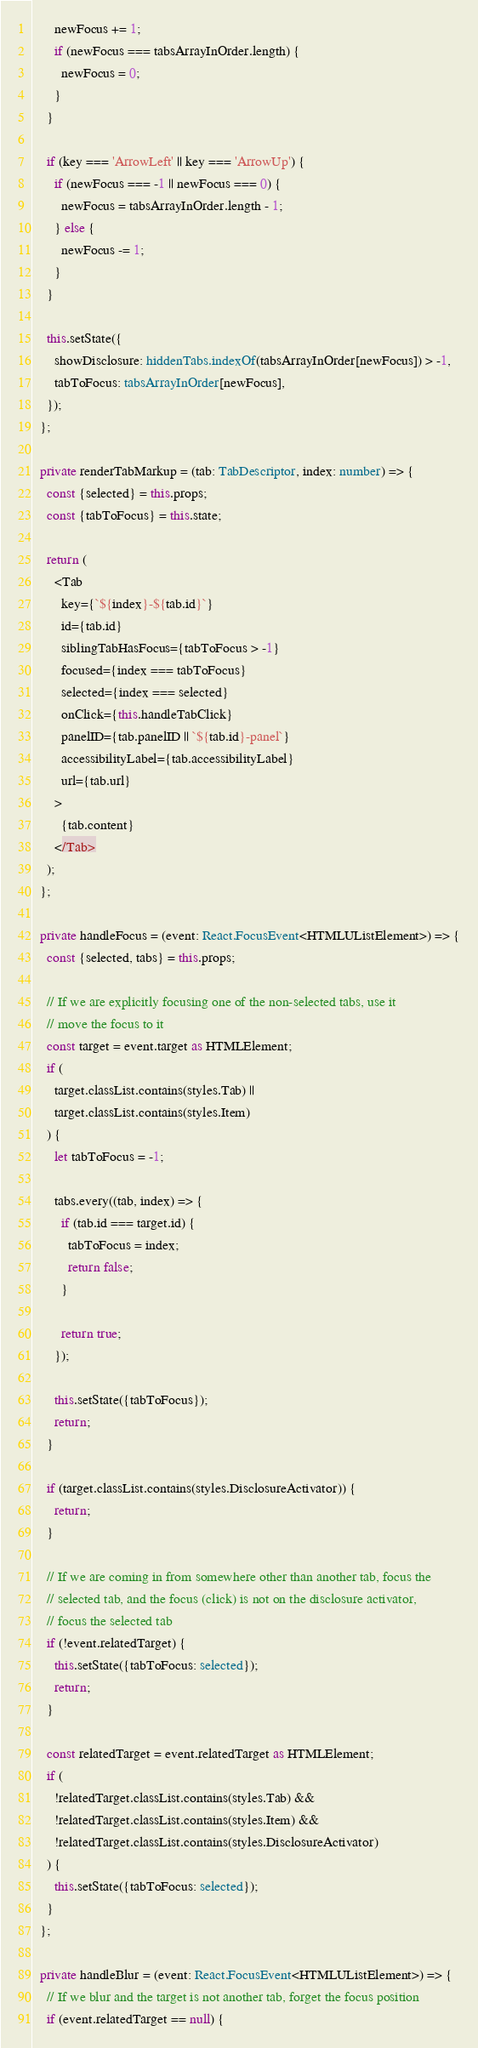<code> <loc_0><loc_0><loc_500><loc_500><_TypeScript_>      newFocus += 1;
      if (newFocus === tabsArrayInOrder.length) {
        newFocus = 0;
      }
    }

    if (key === 'ArrowLeft' || key === 'ArrowUp') {
      if (newFocus === -1 || newFocus === 0) {
        newFocus = tabsArrayInOrder.length - 1;
      } else {
        newFocus -= 1;
      }
    }

    this.setState({
      showDisclosure: hiddenTabs.indexOf(tabsArrayInOrder[newFocus]) > -1,
      tabToFocus: tabsArrayInOrder[newFocus],
    });
  };

  private renderTabMarkup = (tab: TabDescriptor, index: number) => {
    const {selected} = this.props;
    const {tabToFocus} = this.state;

    return (
      <Tab
        key={`${index}-${tab.id}`}
        id={tab.id}
        siblingTabHasFocus={tabToFocus > -1}
        focused={index === tabToFocus}
        selected={index === selected}
        onClick={this.handleTabClick}
        panelID={tab.panelID || `${tab.id}-panel`}
        accessibilityLabel={tab.accessibilityLabel}
        url={tab.url}
      >
        {tab.content}
      </Tab>
    );
  };

  private handleFocus = (event: React.FocusEvent<HTMLUListElement>) => {
    const {selected, tabs} = this.props;

    // If we are explicitly focusing one of the non-selected tabs, use it
    // move the focus to it
    const target = event.target as HTMLElement;
    if (
      target.classList.contains(styles.Tab) ||
      target.classList.contains(styles.Item)
    ) {
      let tabToFocus = -1;

      tabs.every((tab, index) => {
        if (tab.id === target.id) {
          tabToFocus = index;
          return false;
        }

        return true;
      });

      this.setState({tabToFocus});
      return;
    }

    if (target.classList.contains(styles.DisclosureActivator)) {
      return;
    }

    // If we are coming in from somewhere other than another tab, focus the
    // selected tab, and the focus (click) is not on the disclosure activator,
    // focus the selected tab
    if (!event.relatedTarget) {
      this.setState({tabToFocus: selected});
      return;
    }

    const relatedTarget = event.relatedTarget as HTMLElement;
    if (
      !relatedTarget.classList.contains(styles.Tab) &&
      !relatedTarget.classList.contains(styles.Item) &&
      !relatedTarget.classList.contains(styles.DisclosureActivator)
    ) {
      this.setState({tabToFocus: selected});
    }
  };

  private handleBlur = (event: React.FocusEvent<HTMLUListElement>) => {
    // If we blur and the target is not another tab, forget the focus position
    if (event.relatedTarget == null) {</code> 